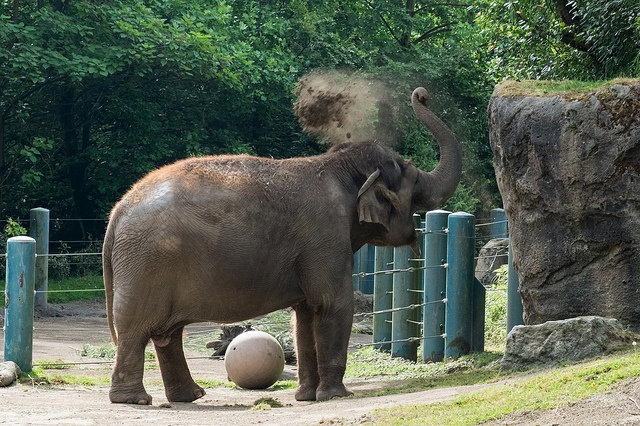Describe the objects in this image and their specific colors. I can see elephant in darkgreen, black, and gray tones and sports ball in darkgreen, darkgray, gray, and white tones in this image. 